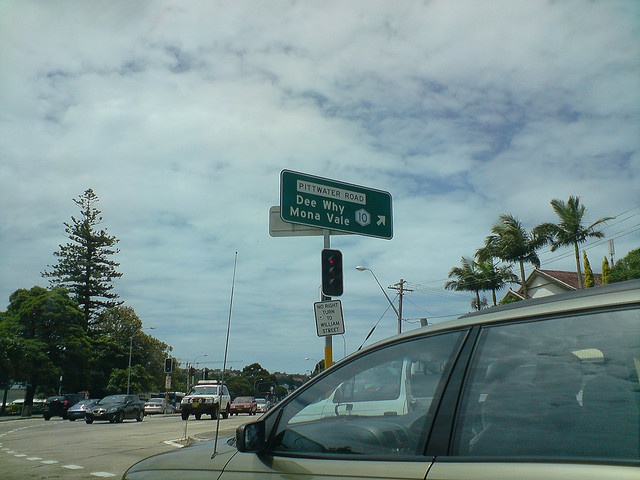Describe the objects in this image and their specific colors. I can see car in lightblue, gray, teal, black, and darkgray tones, people in lightblue, teal, darkblue, and purple tones, car in lightblue, black, gray, darkgray, and darkgreen tones, car in lightblue, black, gray, and teal tones, and traffic light in lightblue, black, darkgray, teal, and gray tones in this image. 